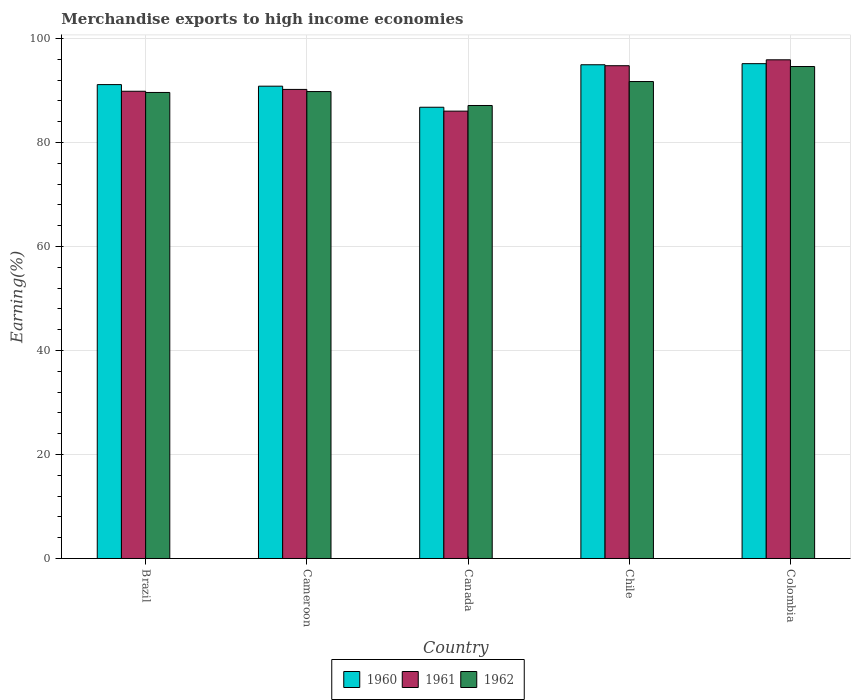What is the percentage of amount earned from merchandise exports in 1962 in Cameroon?
Provide a succinct answer. 89.78. Across all countries, what is the maximum percentage of amount earned from merchandise exports in 1961?
Keep it short and to the point. 95.89. Across all countries, what is the minimum percentage of amount earned from merchandise exports in 1961?
Offer a terse response. 86.02. In which country was the percentage of amount earned from merchandise exports in 1960 maximum?
Ensure brevity in your answer.  Colombia. What is the total percentage of amount earned from merchandise exports in 1960 in the graph?
Offer a terse response. 458.78. What is the difference between the percentage of amount earned from merchandise exports in 1960 in Brazil and that in Cameroon?
Ensure brevity in your answer.  0.3. What is the difference between the percentage of amount earned from merchandise exports in 1961 in Cameroon and the percentage of amount earned from merchandise exports in 1962 in Chile?
Provide a short and direct response. -1.51. What is the average percentage of amount earned from merchandise exports in 1962 per country?
Provide a succinct answer. 90.56. What is the difference between the percentage of amount earned from merchandise exports of/in 1962 and percentage of amount earned from merchandise exports of/in 1960 in Brazil?
Provide a short and direct response. -1.51. In how many countries, is the percentage of amount earned from merchandise exports in 1962 greater than 64 %?
Give a very brief answer. 5. What is the ratio of the percentage of amount earned from merchandise exports in 1962 in Cameroon to that in Canada?
Provide a succinct answer. 1.03. Is the difference between the percentage of amount earned from merchandise exports in 1962 in Canada and Chile greater than the difference between the percentage of amount earned from merchandise exports in 1960 in Canada and Chile?
Give a very brief answer. Yes. What is the difference between the highest and the second highest percentage of amount earned from merchandise exports in 1962?
Make the answer very short. -1.93. What is the difference between the highest and the lowest percentage of amount earned from merchandise exports in 1960?
Give a very brief answer. 8.38. Is the sum of the percentage of amount earned from merchandise exports in 1961 in Cameroon and Chile greater than the maximum percentage of amount earned from merchandise exports in 1962 across all countries?
Provide a succinct answer. Yes. What does the 2nd bar from the right in Chile represents?
Keep it short and to the point. 1961. Is it the case that in every country, the sum of the percentage of amount earned from merchandise exports in 1962 and percentage of amount earned from merchandise exports in 1961 is greater than the percentage of amount earned from merchandise exports in 1960?
Keep it short and to the point. Yes. Are the values on the major ticks of Y-axis written in scientific E-notation?
Ensure brevity in your answer.  No. Does the graph contain any zero values?
Provide a short and direct response. No. Does the graph contain grids?
Ensure brevity in your answer.  Yes. Where does the legend appear in the graph?
Offer a very short reply. Bottom center. How are the legend labels stacked?
Make the answer very short. Horizontal. What is the title of the graph?
Provide a succinct answer. Merchandise exports to high income economies. Does "1996" appear as one of the legend labels in the graph?
Your answer should be compact. No. What is the label or title of the X-axis?
Provide a short and direct response. Country. What is the label or title of the Y-axis?
Give a very brief answer. Earning(%). What is the Earning(%) in 1960 in Brazil?
Offer a very short reply. 91.12. What is the Earning(%) in 1961 in Brazil?
Keep it short and to the point. 89.84. What is the Earning(%) of 1962 in Brazil?
Keep it short and to the point. 89.61. What is the Earning(%) in 1960 in Cameroon?
Your response must be concise. 90.82. What is the Earning(%) of 1961 in Cameroon?
Offer a terse response. 90.19. What is the Earning(%) in 1962 in Cameroon?
Provide a succinct answer. 89.78. What is the Earning(%) of 1960 in Canada?
Make the answer very short. 86.77. What is the Earning(%) of 1961 in Canada?
Your response must be concise. 86.02. What is the Earning(%) in 1962 in Canada?
Your answer should be very brief. 87.1. What is the Earning(%) of 1960 in Chile?
Keep it short and to the point. 94.94. What is the Earning(%) in 1961 in Chile?
Offer a very short reply. 94.75. What is the Earning(%) of 1962 in Chile?
Provide a short and direct response. 91.71. What is the Earning(%) in 1960 in Colombia?
Your answer should be very brief. 95.14. What is the Earning(%) in 1961 in Colombia?
Provide a short and direct response. 95.89. What is the Earning(%) of 1962 in Colombia?
Provide a succinct answer. 94.6. Across all countries, what is the maximum Earning(%) in 1960?
Make the answer very short. 95.14. Across all countries, what is the maximum Earning(%) of 1961?
Your answer should be very brief. 95.89. Across all countries, what is the maximum Earning(%) of 1962?
Provide a short and direct response. 94.6. Across all countries, what is the minimum Earning(%) in 1960?
Offer a very short reply. 86.77. Across all countries, what is the minimum Earning(%) in 1961?
Your response must be concise. 86.02. Across all countries, what is the minimum Earning(%) of 1962?
Your answer should be compact. 87.1. What is the total Earning(%) in 1960 in the graph?
Your answer should be very brief. 458.78. What is the total Earning(%) of 1961 in the graph?
Your answer should be very brief. 456.69. What is the total Earning(%) of 1962 in the graph?
Your answer should be very brief. 452.8. What is the difference between the Earning(%) of 1960 in Brazil and that in Cameroon?
Offer a very short reply. 0.3. What is the difference between the Earning(%) in 1961 in Brazil and that in Cameroon?
Offer a very short reply. -0.35. What is the difference between the Earning(%) of 1962 in Brazil and that in Cameroon?
Your answer should be compact. -0.17. What is the difference between the Earning(%) of 1960 in Brazil and that in Canada?
Your answer should be compact. 4.35. What is the difference between the Earning(%) in 1961 in Brazil and that in Canada?
Offer a very short reply. 3.82. What is the difference between the Earning(%) in 1962 in Brazil and that in Canada?
Your answer should be compact. 2.51. What is the difference between the Earning(%) of 1960 in Brazil and that in Chile?
Make the answer very short. -3.82. What is the difference between the Earning(%) of 1961 in Brazil and that in Chile?
Keep it short and to the point. -4.91. What is the difference between the Earning(%) of 1962 in Brazil and that in Chile?
Your answer should be very brief. -2.1. What is the difference between the Earning(%) of 1960 in Brazil and that in Colombia?
Ensure brevity in your answer.  -4.03. What is the difference between the Earning(%) of 1961 in Brazil and that in Colombia?
Your response must be concise. -6.05. What is the difference between the Earning(%) of 1962 in Brazil and that in Colombia?
Offer a terse response. -4.99. What is the difference between the Earning(%) of 1960 in Cameroon and that in Canada?
Your answer should be compact. 4.05. What is the difference between the Earning(%) in 1961 in Cameroon and that in Canada?
Provide a short and direct response. 4.18. What is the difference between the Earning(%) of 1962 in Cameroon and that in Canada?
Your response must be concise. 2.68. What is the difference between the Earning(%) in 1960 in Cameroon and that in Chile?
Offer a terse response. -4.12. What is the difference between the Earning(%) in 1961 in Cameroon and that in Chile?
Offer a terse response. -4.56. What is the difference between the Earning(%) in 1962 in Cameroon and that in Chile?
Make the answer very short. -1.93. What is the difference between the Earning(%) of 1960 in Cameroon and that in Colombia?
Give a very brief answer. -4.33. What is the difference between the Earning(%) in 1961 in Cameroon and that in Colombia?
Ensure brevity in your answer.  -5.69. What is the difference between the Earning(%) of 1962 in Cameroon and that in Colombia?
Make the answer very short. -4.81. What is the difference between the Earning(%) of 1960 in Canada and that in Chile?
Keep it short and to the point. -8.17. What is the difference between the Earning(%) in 1961 in Canada and that in Chile?
Provide a succinct answer. -8.73. What is the difference between the Earning(%) of 1962 in Canada and that in Chile?
Provide a succinct answer. -4.61. What is the difference between the Earning(%) in 1960 in Canada and that in Colombia?
Give a very brief answer. -8.38. What is the difference between the Earning(%) in 1961 in Canada and that in Colombia?
Provide a short and direct response. -9.87. What is the difference between the Earning(%) in 1962 in Canada and that in Colombia?
Make the answer very short. -7.5. What is the difference between the Earning(%) of 1960 in Chile and that in Colombia?
Your answer should be compact. -0.21. What is the difference between the Earning(%) in 1961 in Chile and that in Colombia?
Offer a terse response. -1.14. What is the difference between the Earning(%) of 1962 in Chile and that in Colombia?
Make the answer very short. -2.89. What is the difference between the Earning(%) of 1960 in Brazil and the Earning(%) of 1961 in Cameroon?
Ensure brevity in your answer.  0.92. What is the difference between the Earning(%) of 1960 in Brazil and the Earning(%) of 1962 in Cameroon?
Provide a short and direct response. 1.34. What is the difference between the Earning(%) of 1961 in Brazil and the Earning(%) of 1962 in Cameroon?
Ensure brevity in your answer.  0.06. What is the difference between the Earning(%) in 1960 in Brazil and the Earning(%) in 1961 in Canada?
Offer a very short reply. 5.1. What is the difference between the Earning(%) of 1960 in Brazil and the Earning(%) of 1962 in Canada?
Your answer should be compact. 4.02. What is the difference between the Earning(%) in 1961 in Brazil and the Earning(%) in 1962 in Canada?
Offer a terse response. 2.74. What is the difference between the Earning(%) of 1960 in Brazil and the Earning(%) of 1961 in Chile?
Your response must be concise. -3.63. What is the difference between the Earning(%) of 1960 in Brazil and the Earning(%) of 1962 in Chile?
Your response must be concise. -0.59. What is the difference between the Earning(%) of 1961 in Brazil and the Earning(%) of 1962 in Chile?
Your answer should be very brief. -1.87. What is the difference between the Earning(%) in 1960 in Brazil and the Earning(%) in 1961 in Colombia?
Keep it short and to the point. -4.77. What is the difference between the Earning(%) of 1960 in Brazil and the Earning(%) of 1962 in Colombia?
Provide a succinct answer. -3.48. What is the difference between the Earning(%) of 1961 in Brazil and the Earning(%) of 1962 in Colombia?
Your response must be concise. -4.76. What is the difference between the Earning(%) in 1960 in Cameroon and the Earning(%) in 1961 in Canada?
Ensure brevity in your answer.  4.8. What is the difference between the Earning(%) in 1960 in Cameroon and the Earning(%) in 1962 in Canada?
Your response must be concise. 3.71. What is the difference between the Earning(%) of 1961 in Cameroon and the Earning(%) of 1962 in Canada?
Offer a very short reply. 3.09. What is the difference between the Earning(%) in 1960 in Cameroon and the Earning(%) in 1961 in Chile?
Provide a short and direct response. -3.94. What is the difference between the Earning(%) in 1960 in Cameroon and the Earning(%) in 1962 in Chile?
Make the answer very short. -0.89. What is the difference between the Earning(%) in 1961 in Cameroon and the Earning(%) in 1962 in Chile?
Your answer should be compact. -1.51. What is the difference between the Earning(%) in 1960 in Cameroon and the Earning(%) in 1961 in Colombia?
Provide a succinct answer. -5.07. What is the difference between the Earning(%) in 1960 in Cameroon and the Earning(%) in 1962 in Colombia?
Ensure brevity in your answer.  -3.78. What is the difference between the Earning(%) in 1961 in Cameroon and the Earning(%) in 1962 in Colombia?
Your answer should be very brief. -4.4. What is the difference between the Earning(%) in 1960 in Canada and the Earning(%) in 1961 in Chile?
Offer a very short reply. -7.98. What is the difference between the Earning(%) of 1960 in Canada and the Earning(%) of 1962 in Chile?
Give a very brief answer. -4.94. What is the difference between the Earning(%) in 1961 in Canada and the Earning(%) in 1962 in Chile?
Offer a very short reply. -5.69. What is the difference between the Earning(%) in 1960 in Canada and the Earning(%) in 1961 in Colombia?
Offer a very short reply. -9.12. What is the difference between the Earning(%) in 1960 in Canada and the Earning(%) in 1962 in Colombia?
Ensure brevity in your answer.  -7.83. What is the difference between the Earning(%) of 1961 in Canada and the Earning(%) of 1962 in Colombia?
Provide a short and direct response. -8.58. What is the difference between the Earning(%) of 1960 in Chile and the Earning(%) of 1961 in Colombia?
Keep it short and to the point. -0.95. What is the difference between the Earning(%) of 1960 in Chile and the Earning(%) of 1962 in Colombia?
Offer a very short reply. 0.34. What is the difference between the Earning(%) of 1961 in Chile and the Earning(%) of 1962 in Colombia?
Keep it short and to the point. 0.15. What is the average Earning(%) of 1960 per country?
Offer a very short reply. 91.76. What is the average Earning(%) of 1961 per country?
Keep it short and to the point. 91.34. What is the average Earning(%) in 1962 per country?
Offer a very short reply. 90.56. What is the difference between the Earning(%) in 1960 and Earning(%) in 1961 in Brazil?
Your response must be concise. 1.28. What is the difference between the Earning(%) in 1960 and Earning(%) in 1962 in Brazil?
Make the answer very short. 1.51. What is the difference between the Earning(%) in 1961 and Earning(%) in 1962 in Brazil?
Keep it short and to the point. 0.23. What is the difference between the Earning(%) of 1960 and Earning(%) of 1961 in Cameroon?
Give a very brief answer. 0.62. What is the difference between the Earning(%) in 1960 and Earning(%) in 1962 in Cameroon?
Your response must be concise. 1.03. What is the difference between the Earning(%) in 1961 and Earning(%) in 1962 in Cameroon?
Ensure brevity in your answer.  0.41. What is the difference between the Earning(%) of 1960 and Earning(%) of 1961 in Canada?
Make the answer very short. 0.75. What is the difference between the Earning(%) of 1960 and Earning(%) of 1962 in Canada?
Provide a succinct answer. -0.33. What is the difference between the Earning(%) of 1961 and Earning(%) of 1962 in Canada?
Offer a very short reply. -1.08. What is the difference between the Earning(%) in 1960 and Earning(%) in 1961 in Chile?
Provide a short and direct response. 0.19. What is the difference between the Earning(%) in 1960 and Earning(%) in 1962 in Chile?
Offer a terse response. 3.23. What is the difference between the Earning(%) of 1961 and Earning(%) of 1962 in Chile?
Your response must be concise. 3.04. What is the difference between the Earning(%) in 1960 and Earning(%) in 1961 in Colombia?
Keep it short and to the point. -0.74. What is the difference between the Earning(%) in 1960 and Earning(%) in 1962 in Colombia?
Keep it short and to the point. 0.55. What is the difference between the Earning(%) of 1961 and Earning(%) of 1962 in Colombia?
Your answer should be compact. 1.29. What is the ratio of the Earning(%) of 1960 in Brazil to that in Cameroon?
Your answer should be very brief. 1. What is the ratio of the Earning(%) in 1961 in Brazil to that in Cameroon?
Offer a very short reply. 1. What is the ratio of the Earning(%) in 1962 in Brazil to that in Cameroon?
Make the answer very short. 1. What is the ratio of the Earning(%) in 1960 in Brazil to that in Canada?
Your response must be concise. 1.05. What is the ratio of the Earning(%) of 1961 in Brazil to that in Canada?
Provide a succinct answer. 1.04. What is the ratio of the Earning(%) in 1962 in Brazil to that in Canada?
Keep it short and to the point. 1.03. What is the ratio of the Earning(%) in 1960 in Brazil to that in Chile?
Provide a succinct answer. 0.96. What is the ratio of the Earning(%) of 1961 in Brazil to that in Chile?
Ensure brevity in your answer.  0.95. What is the ratio of the Earning(%) in 1962 in Brazil to that in Chile?
Your response must be concise. 0.98. What is the ratio of the Earning(%) of 1960 in Brazil to that in Colombia?
Give a very brief answer. 0.96. What is the ratio of the Earning(%) of 1961 in Brazil to that in Colombia?
Provide a succinct answer. 0.94. What is the ratio of the Earning(%) of 1962 in Brazil to that in Colombia?
Give a very brief answer. 0.95. What is the ratio of the Earning(%) in 1960 in Cameroon to that in Canada?
Your response must be concise. 1.05. What is the ratio of the Earning(%) in 1961 in Cameroon to that in Canada?
Your response must be concise. 1.05. What is the ratio of the Earning(%) of 1962 in Cameroon to that in Canada?
Give a very brief answer. 1.03. What is the ratio of the Earning(%) of 1960 in Cameroon to that in Chile?
Your response must be concise. 0.96. What is the ratio of the Earning(%) in 1961 in Cameroon to that in Chile?
Ensure brevity in your answer.  0.95. What is the ratio of the Earning(%) of 1960 in Cameroon to that in Colombia?
Make the answer very short. 0.95. What is the ratio of the Earning(%) of 1961 in Cameroon to that in Colombia?
Offer a terse response. 0.94. What is the ratio of the Earning(%) of 1962 in Cameroon to that in Colombia?
Offer a very short reply. 0.95. What is the ratio of the Earning(%) in 1960 in Canada to that in Chile?
Give a very brief answer. 0.91. What is the ratio of the Earning(%) of 1961 in Canada to that in Chile?
Offer a very short reply. 0.91. What is the ratio of the Earning(%) in 1962 in Canada to that in Chile?
Provide a succinct answer. 0.95. What is the ratio of the Earning(%) of 1960 in Canada to that in Colombia?
Ensure brevity in your answer.  0.91. What is the ratio of the Earning(%) of 1961 in Canada to that in Colombia?
Your answer should be very brief. 0.9. What is the ratio of the Earning(%) of 1962 in Canada to that in Colombia?
Make the answer very short. 0.92. What is the ratio of the Earning(%) of 1962 in Chile to that in Colombia?
Provide a short and direct response. 0.97. What is the difference between the highest and the second highest Earning(%) in 1960?
Provide a short and direct response. 0.21. What is the difference between the highest and the second highest Earning(%) of 1961?
Provide a short and direct response. 1.14. What is the difference between the highest and the second highest Earning(%) of 1962?
Your answer should be very brief. 2.89. What is the difference between the highest and the lowest Earning(%) in 1960?
Your answer should be very brief. 8.38. What is the difference between the highest and the lowest Earning(%) of 1961?
Your answer should be very brief. 9.87. What is the difference between the highest and the lowest Earning(%) of 1962?
Ensure brevity in your answer.  7.5. 